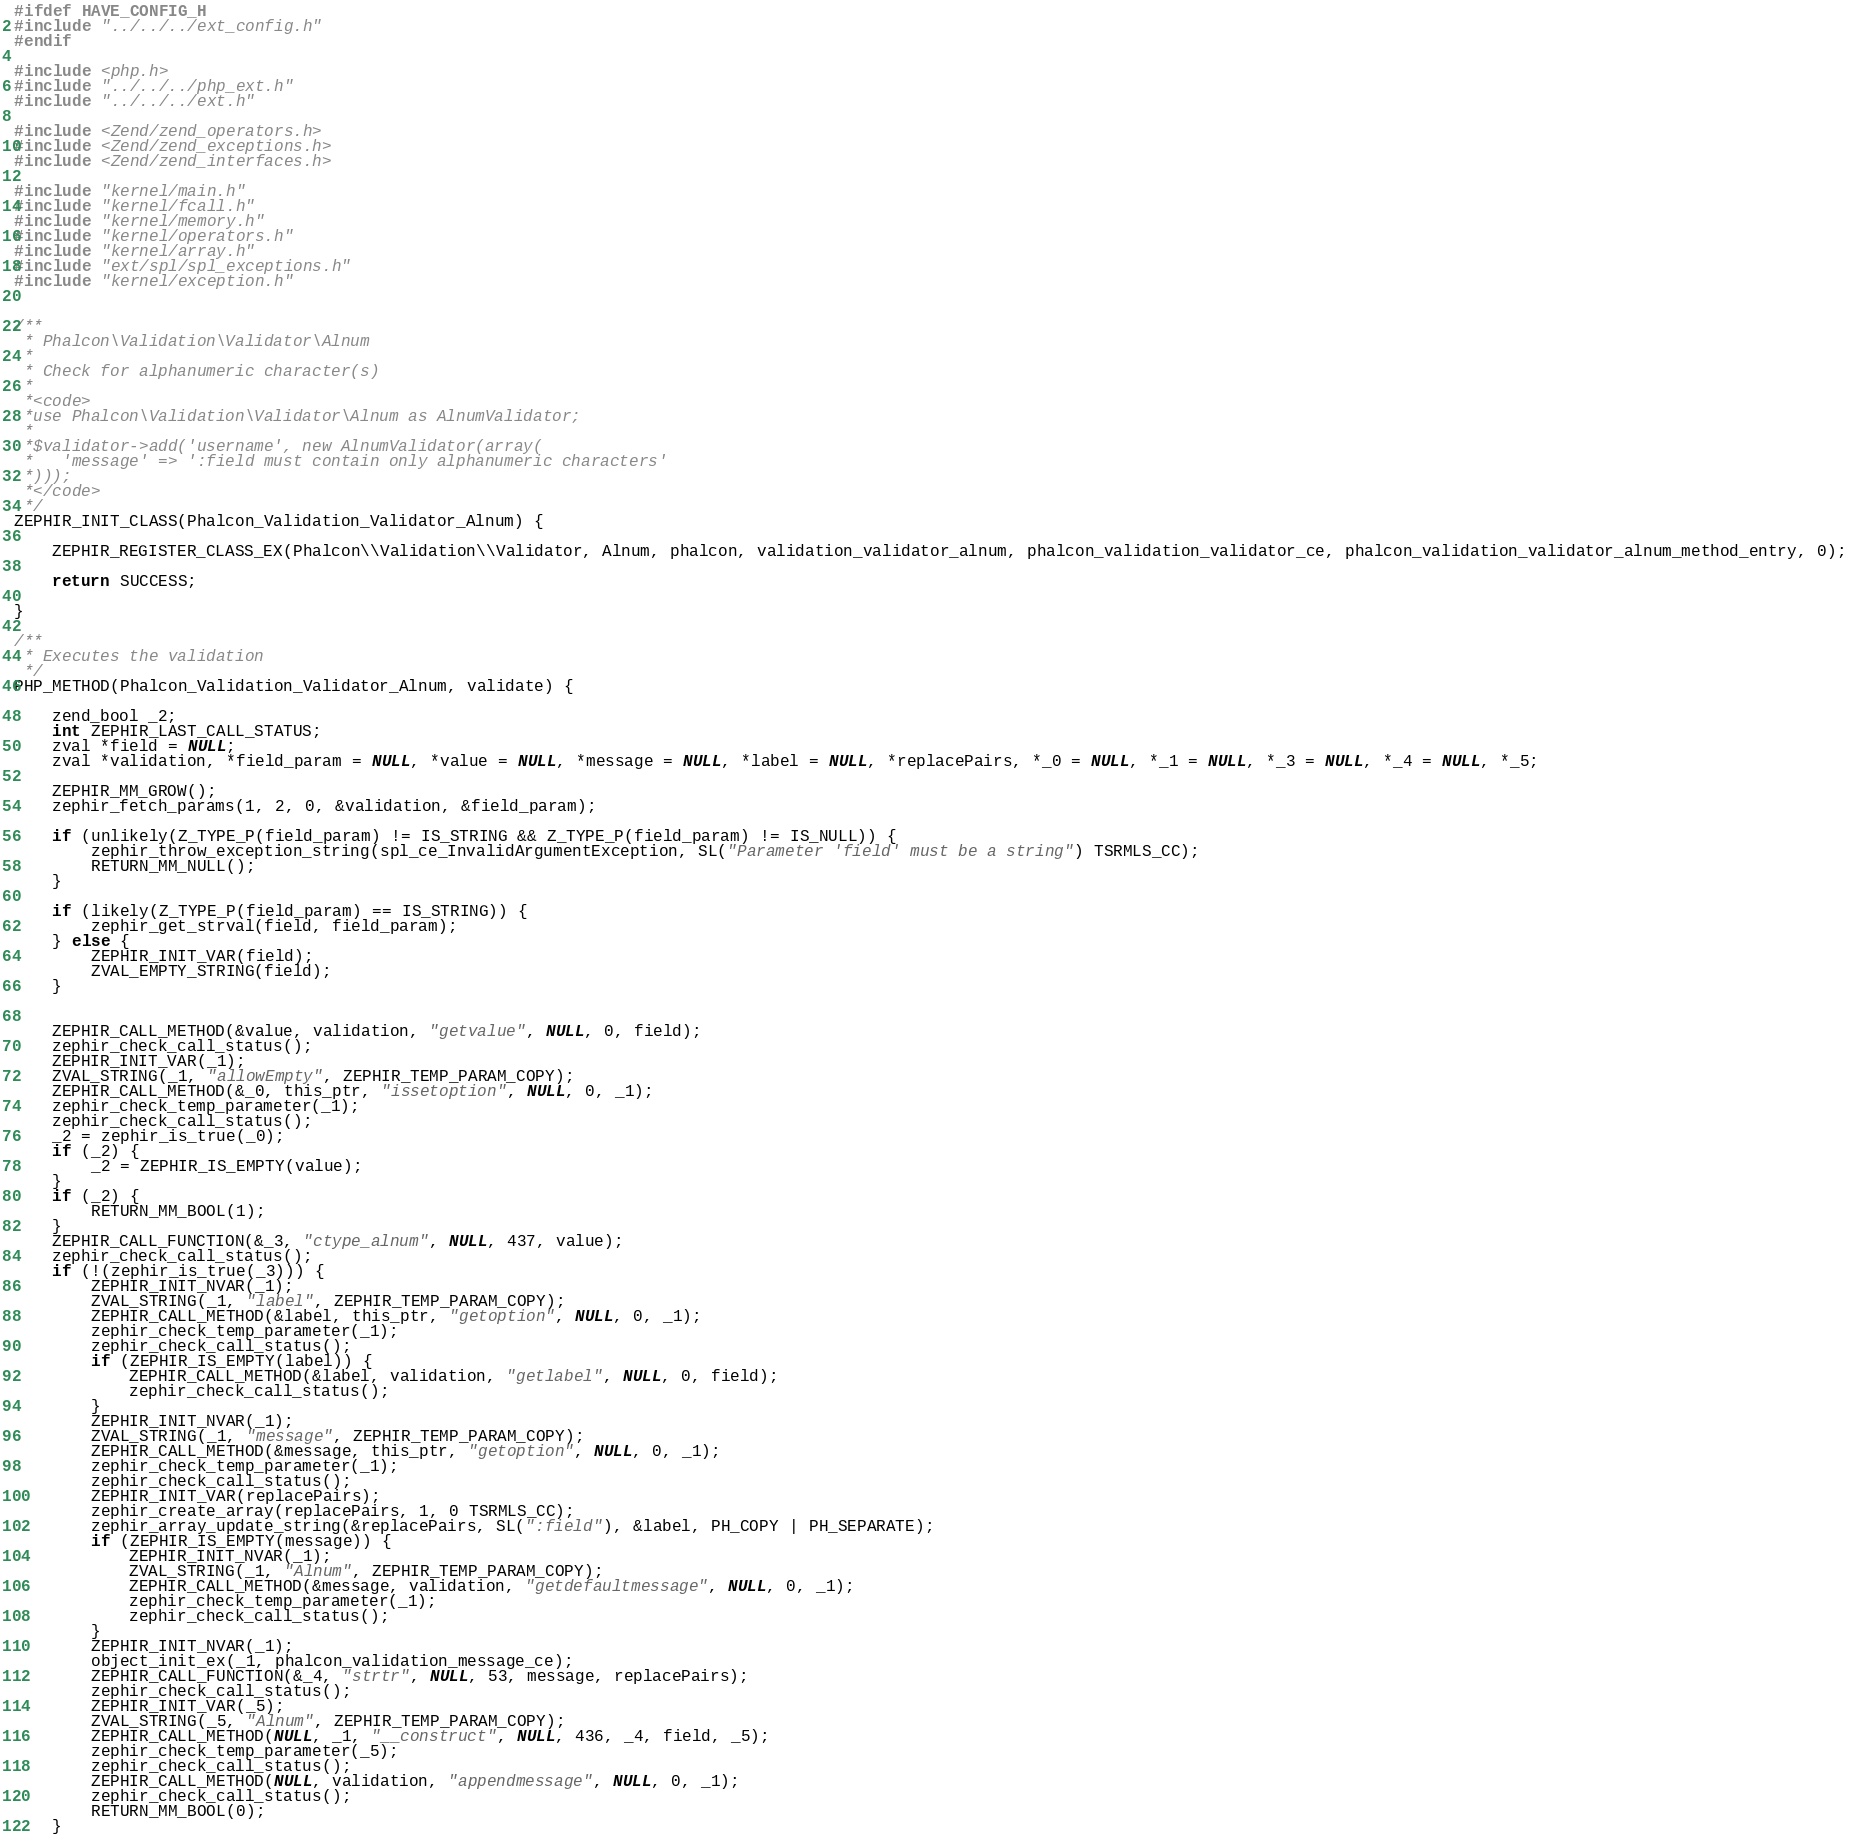Convert code to text. <code><loc_0><loc_0><loc_500><loc_500><_C_>
#ifdef HAVE_CONFIG_H
#include "../../../ext_config.h"
#endif

#include <php.h>
#include "../../../php_ext.h"
#include "../../../ext.h"

#include <Zend/zend_operators.h>
#include <Zend/zend_exceptions.h>
#include <Zend/zend_interfaces.h>

#include "kernel/main.h"
#include "kernel/fcall.h"
#include "kernel/memory.h"
#include "kernel/operators.h"
#include "kernel/array.h"
#include "ext/spl/spl_exceptions.h"
#include "kernel/exception.h"


/**
 * Phalcon\Validation\Validator\Alnum
 *
 * Check for alphanumeric character(s)
 *
 *<code>
 *use Phalcon\Validation\Validator\Alnum as AlnumValidator;
 *
 *$validator->add('username', new AlnumValidator(array(
 *   'message' => ':field must contain only alphanumeric characters'
 *)));
 *</code>
 */
ZEPHIR_INIT_CLASS(Phalcon_Validation_Validator_Alnum) {

	ZEPHIR_REGISTER_CLASS_EX(Phalcon\\Validation\\Validator, Alnum, phalcon, validation_validator_alnum, phalcon_validation_validator_ce, phalcon_validation_validator_alnum_method_entry, 0);

	return SUCCESS;

}

/**
 * Executes the validation
 */
PHP_METHOD(Phalcon_Validation_Validator_Alnum, validate) {

	zend_bool _2;
	int ZEPHIR_LAST_CALL_STATUS;
	zval *field = NULL;
	zval *validation, *field_param = NULL, *value = NULL, *message = NULL, *label = NULL, *replacePairs, *_0 = NULL, *_1 = NULL, *_3 = NULL, *_4 = NULL, *_5;

	ZEPHIR_MM_GROW();
	zephir_fetch_params(1, 2, 0, &validation, &field_param);

	if (unlikely(Z_TYPE_P(field_param) != IS_STRING && Z_TYPE_P(field_param) != IS_NULL)) {
		zephir_throw_exception_string(spl_ce_InvalidArgumentException, SL("Parameter 'field' must be a string") TSRMLS_CC);
		RETURN_MM_NULL();
	}

	if (likely(Z_TYPE_P(field_param) == IS_STRING)) {
		zephir_get_strval(field, field_param);
	} else {
		ZEPHIR_INIT_VAR(field);
		ZVAL_EMPTY_STRING(field);
	}


	ZEPHIR_CALL_METHOD(&value, validation, "getvalue", NULL, 0, field);
	zephir_check_call_status();
	ZEPHIR_INIT_VAR(_1);
	ZVAL_STRING(_1, "allowEmpty", ZEPHIR_TEMP_PARAM_COPY);
	ZEPHIR_CALL_METHOD(&_0, this_ptr, "issetoption", NULL, 0, _1);
	zephir_check_temp_parameter(_1);
	zephir_check_call_status();
	_2 = zephir_is_true(_0);
	if (_2) {
		_2 = ZEPHIR_IS_EMPTY(value);
	}
	if (_2) {
		RETURN_MM_BOOL(1);
	}
	ZEPHIR_CALL_FUNCTION(&_3, "ctype_alnum", NULL, 437, value);
	zephir_check_call_status();
	if (!(zephir_is_true(_3))) {
		ZEPHIR_INIT_NVAR(_1);
		ZVAL_STRING(_1, "label", ZEPHIR_TEMP_PARAM_COPY);
		ZEPHIR_CALL_METHOD(&label, this_ptr, "getoption", NULL, 0, _1);
		zephir_check_temp_parameter(_1);
		zephir_check_call_status();
		if (ZEPHIR_IS_EMPTY(label)) {
			ZEPHIR_CALL_METHOD(&label, validation, "getlabel", NULL, 0, field);
			zephir_check_call_status();
		}
		ZEPHIR_INIT_NVAR(_1);
		ZVAL_STRING(_1, "message", ZEPHIR_TEMP_PARAM_COPY);
		ZEPHIR_CALL_METHOD(&message, this_ptr, "getoption", NULL, 0, _1);
		zephir_check_temp_parameter(_1);
		zephir_check_call_status();
		ZEPHIR_INIT_VAR(replacePairs);
		zephir_create_array(replacePairs, 1, 0 TSRMLS_CC);
		zephir_array_update_string(&replacePairs, SL(":field"), &label, PH_COPY | PH_SEPARATE);
		if (ZEPHIR_IS_EMPTY(message)) {
			ZEPHIR_INIT_NVAR(_1);
			ZVAL_STRING(_1, "Alnum", ZEPHIR_TEMP_PARAM_COPY);
			ZEPHIR_CALL_METHOD(&message, validation, "getdefaultmessage", NULL, 0, _1);
			zephir_check_temp_parameter(_1);
			zephir_check_call_status();
		}
		ZEPHIR_INIT_NVAR(_1);
		object_init_ex(_1, phalcon_validation_message_ce);
		ZEPHIR_CALL_FUNCTION(&_4, "strtr", NULL, 53, message, replacePairs);
		zephir_check_call_status();
		ZEPHIR_INIT_VAR(_5);
		ZVAL_STRING(_5, "Alnum", ZEPHIR_TEMP_PARAM_COPY);
		ZEPHIR_CALL_METHOD(NULL, _1, "__construct", NULL, 436, _4, field, _5);
		zephir_check_temp_parameter(_5);
		zephir_check_call_status();
		ZEPHIR_CALL_METHOD(NULL, validation, "appendmessage", NULL, 0, _1);
		zephir_check_call_status();
		RETURN_MM_BOOL(0);
	}</code> 